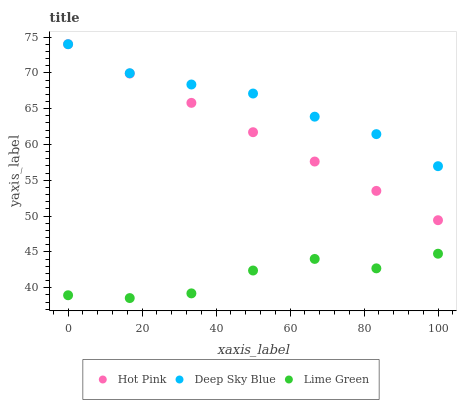Does Lime Green have the minimum area under the curve?
Answer yes or no. Yes. Does Deep Sky Blue have the maximum area under the curve?
Answer yes or no. Yes. Does Deep Sky Blue have the minimum area under the curve?
Answer yes or no. No. Does Lime Green have the maximum area under the curve?
Answer yes or no. No. Is Hot Pink the smoothest?
Answer yes or no. Yes. Is Lime Green the roughest?
Answer yes or no. Yes. Is Deep Sky Blue the smoothest?
Answer yes or no. No. Is Deep Sky Blue the roughest?
Answer yes or no. No. Does Lime Green have the lowest value?
Answer yes or no. Yes. Does Deep Sky Blue have the lowest value?
Answer yes or no. No. Does Deep Sky Blue have the highest value?
Answer yes or no. Yes. Does Lime Green have the highest value?
Answer yes or no. No. Is Lime Green less than Deep Sky Blue?
Answer yes or no. Yes. Is Hot Pink greater than Lime Green?
Answer yes or no. Yes. Does Hot Pink intersect Deep Sky Blue?
Answer yes or no. Yes. Is Hot Pink less than Deep Sky Blue?
Answer yes or no. No. Is Hot Pink greater than Deep Sky Blue?
Answer yes or no. No. Does Lime Green intersect Deep Sky Blue?
Answer yes or no. No. 